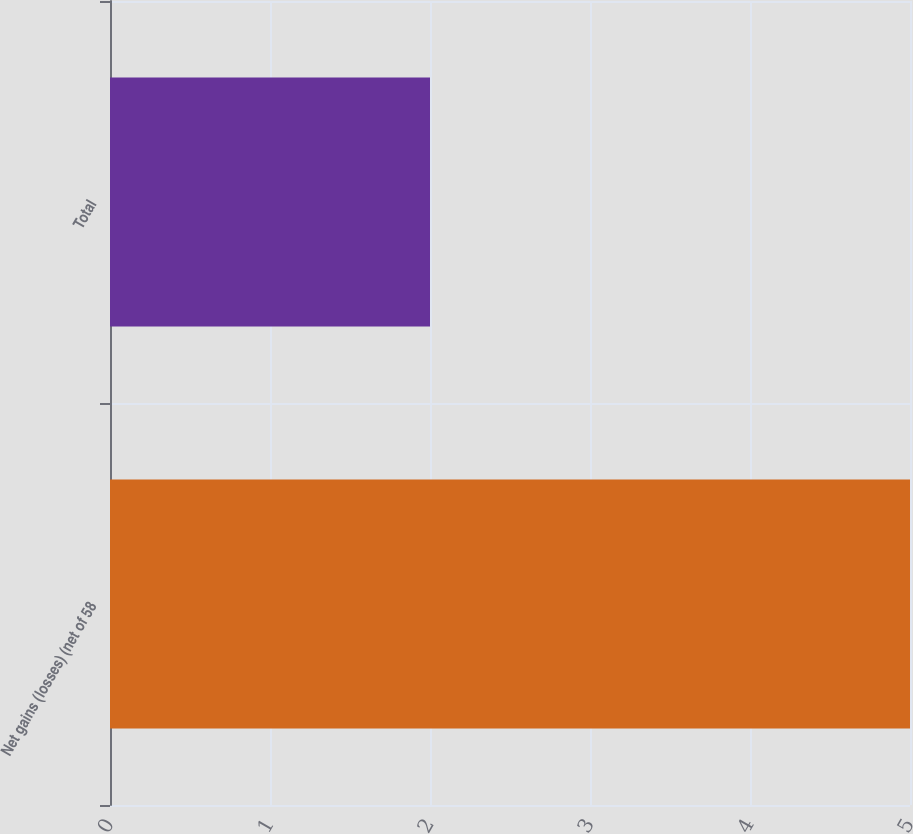<chart> <loc_0><loc_0><loc_500><loc_500><bar_chart><fcel>Net gains (losses) (net of 58<fcel>Total<nl><fcel>5<fcel>2<nl></chart> 